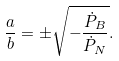Convert formula to latex. <formula><loc_0><loc_0><loc_500><loc_500>\frac { a } { b } = \pm \sqrt { - \frac { { \dot { P } } _ { B } } { { \dot { P } } _ { N } } } .</formula> 